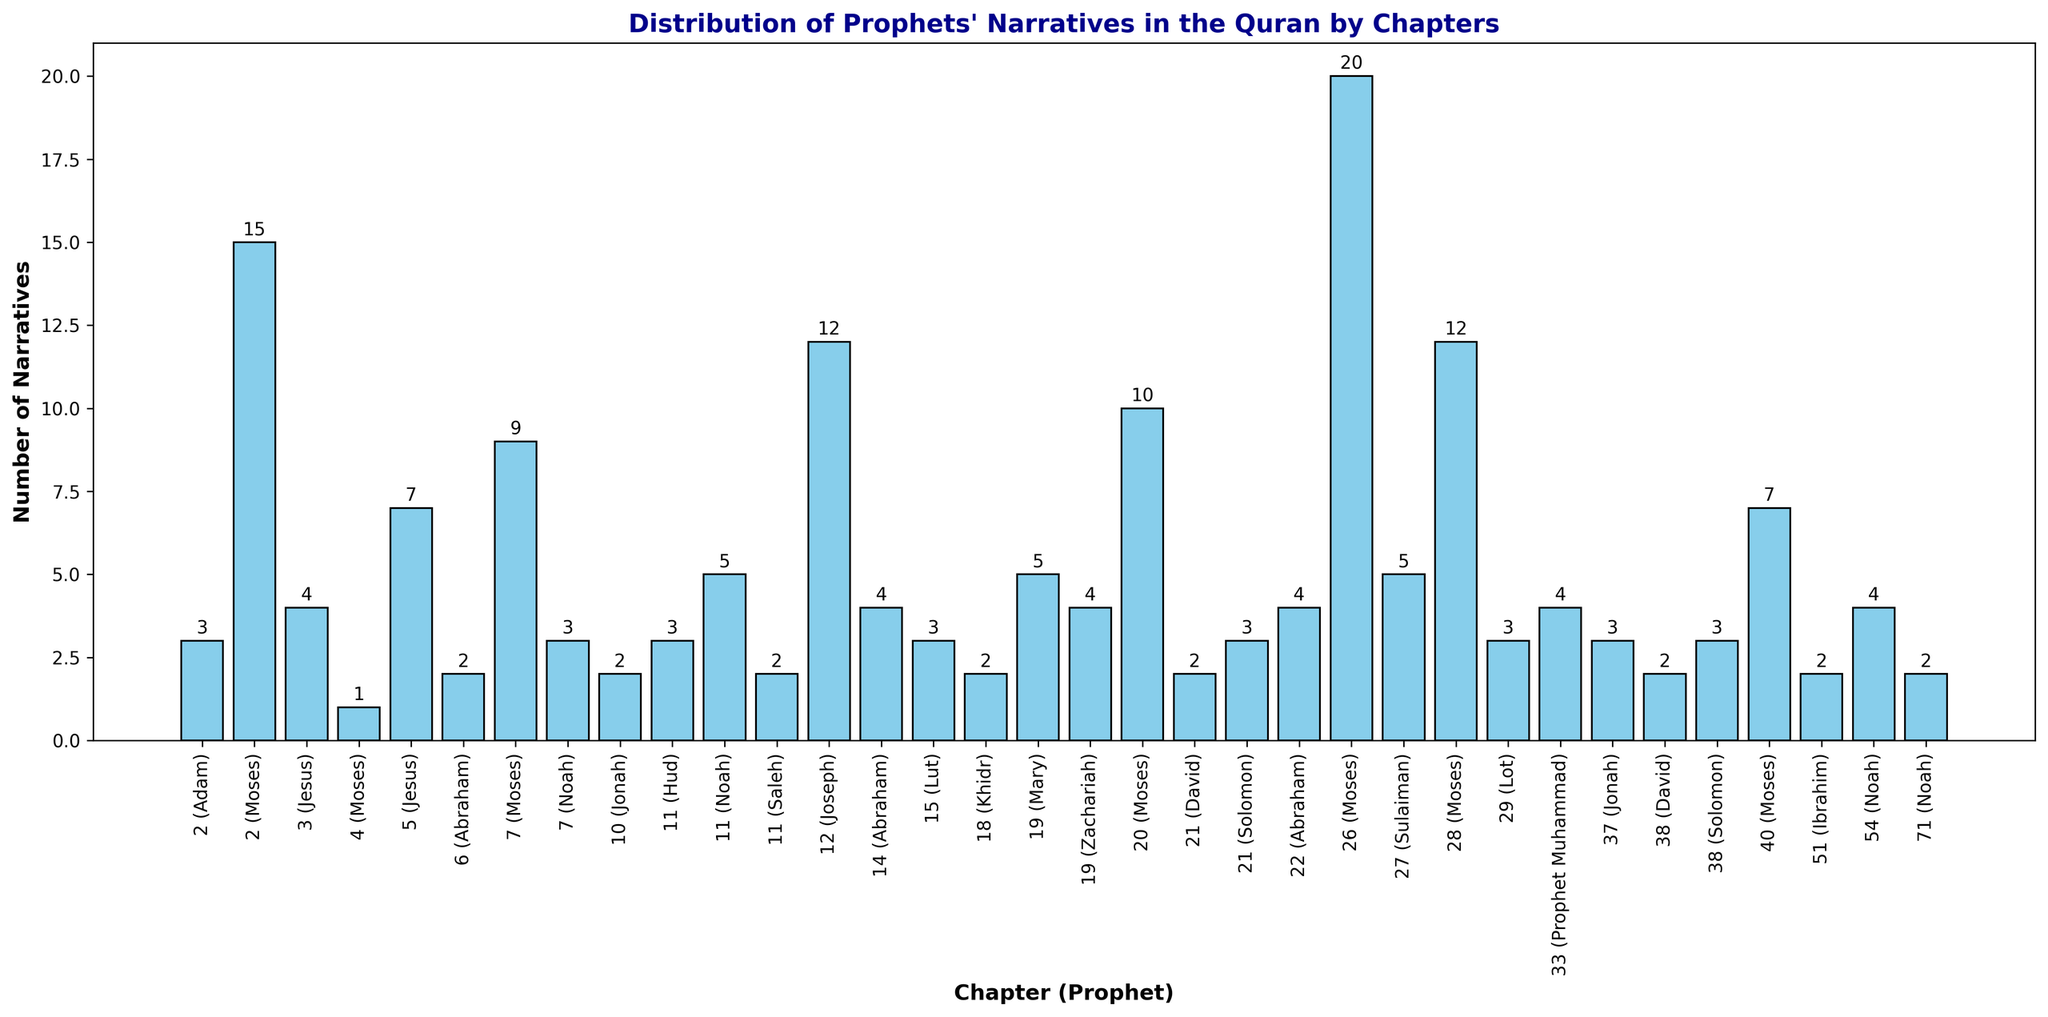Which chapter has the highest number of narratives for Prophet Moses? Look for the chapters associated with Prophet Moses and compare their narrative counts. Chapter 26 has the highest number with 20 narratives.
Answer: 26 How many chapters in total mention Prophet Noah and what is the total number of narratives for him? Identify chapters where Prophet Noah is mentioned and sum their narrative counts: Chapter 7 (3), Chapter 11 (5), Chapter 54 (4), Chapter 71 (2) = 14 narratives in 4 chapters.
Answer: 4 chapters, 14 narratives Compare the number of narratives for Prophet Abraham in Chapters 14 and 22. Are they equal or different? Check the narrative counts for Prophet Abraham in chapters 14 and 22. Both have 4 narratives each, so they are equal.
Answer: Equal Which Prophet is the most frequently mentioned in Chapter 2 and how many narratives are there? Identify Prophets in Chapter 2 and compare their narrative counts. Prophet Moses is mentioned most frequently with 15 narratives.
Answer: Moses, 15 What is the difference in the number of narratives between Prophets Moses and Jesus in Chapter 2? Compare the narrative counts of Moses (15) and Jesus (4) in Chapter 2. The difference is 15 - 3 = 12.
Answer: 12 Is there any Prophet mentioned in Chapter 18, and if so, how many narratives are there? Check if any Prophet is mentioned in Chapter 18 and find their narrative count. Prophet Khidr is mentioned with 2 narratives.
Answer: Yes, 2 narratives Which Prophet is mentioned in both Chapters 21 and 38, and how many narratives are there in each chapter for this Prophet? Identify the common Prophets in Chapters 21 and 38, which are David and Solomon. David has 2 narratives in both chapters, Solomon has 3 in both chapters.
Answer: David and Solomon; David: 2 in each, Solomon: 3 in each Combine the narratives of Prophet Moses from Chapters 2, 4, 7, 20, 26, 28, and 40. What is the total? Sum the narratives for Prophet Moses from the specified chapters: 2 (15), 4 (1), 7 (9), 20 (10), 26 (20), 28 (12), 40 (7) = 74 narratives.
Answer: 74 Which chapter has more narratives of Prophet Jesus, Chapter 5 or Chapter 3? Compare the narrative counts of Prophet Jesus in Chapters 3 (4) and 5 (7). Chapter 5 has more narratives with 7.
Answer: Chapter 5 Identify the Prophet with the least number of total narratives across all chapters and state the total count. Identify the Prophet with the smallest total narrative count. Prophets Hud, Saleh and Ibrahim each have 2 narratives.
Answer: Hud, Saleh, Ibrahim: 2 narratives each 